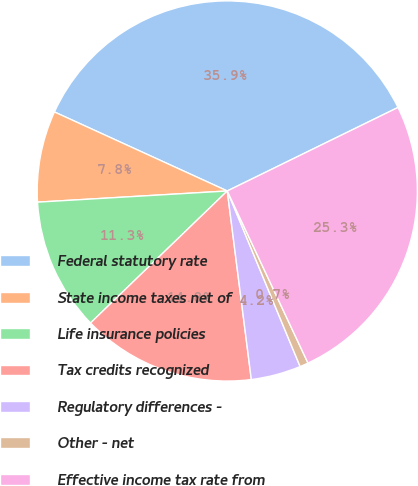Convert chart to OTSL. <chart><loc_0><loc_0><loc_500><loc_500><pie_chart><fcel>Federal statutory rate<fcel>State income taxes net of<fcel>Life insurance policies<fcel>Tax credits recognized<fcel>Regulatory differences -<fcel>Other - net<fcel>Effective income tax rate from<nl><fcel>35.93%<fcel>7.76%<fcel>11.28%<fcel>14.8%<fcel>4.24%<fcel>0.72%<fcel>25.26%<nl></chart> 